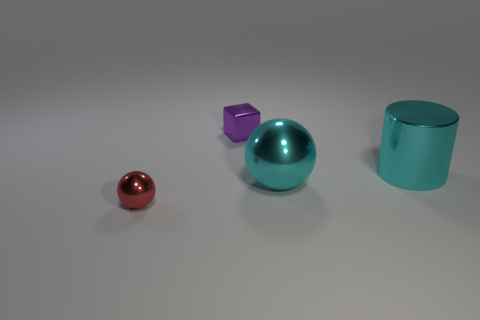Is there anything else that has the same shape as the small purple object?
Your answer should be very brief. No. What number of other objects are the same color as the big metallic cylinder?
Provide a succinct answer. 1. There is a sphere behind the small red sphere; what size is it?
Your answer should be very brief. Large. There is a tiny object behind the red metallic thing; is its color the same as the big cylinder?
Your answer should be very brief. No. What number of large things are the same shape as the small purple object?
Ensure brevity in your answer.  0. What number of things are spheres that are behind the red metallic ball or shiny things that are in front of the purple thing?
Ensure brevity in your answer.  3. What number of purple objects are small metallic objects or big cylinders?
Your answer should be very brief. 1. What material is the object that is both in front of the cyan shiny cylinder and behind the small red metal object?
Offer a terse response. Metal. Is the material of the large cyan ball the same as the purple cube?
Your answer should be very brief. Yes. What number of cylinders are the same size as the cyan shiny sphere?
Offer a terse response. 1. 